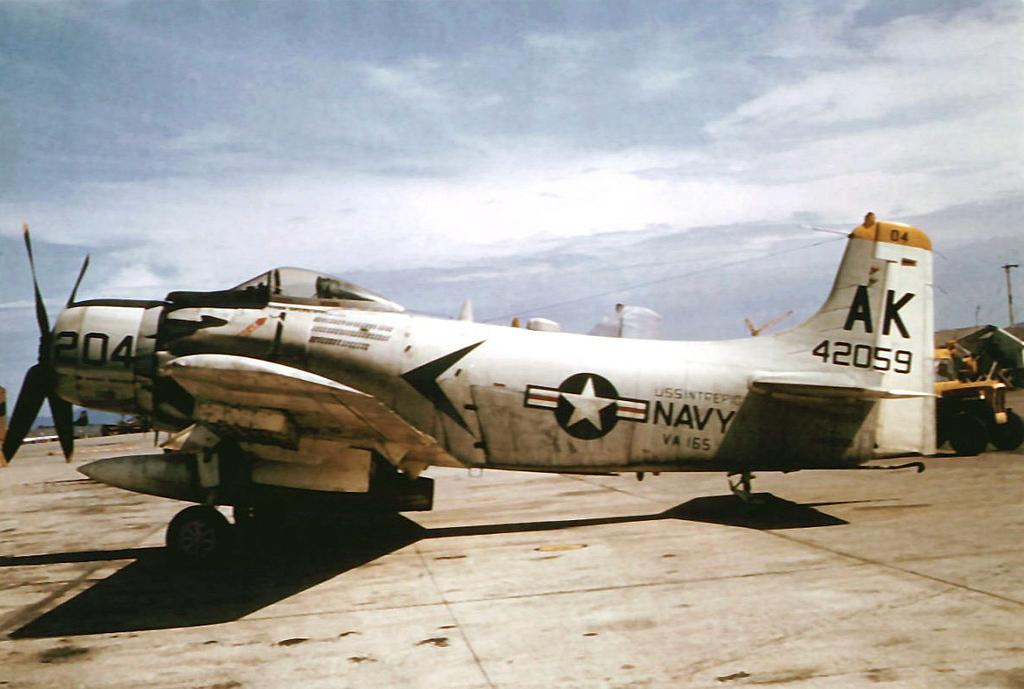What color is the aircraft in the image? The aircraft in the image is white. What is written on the aircraft? "NAVY" is written on the aircraft. What can be seen at the top of the image? The sky is visible at the top of the image. Where is the ornament located in the image? There is no ornament present in the image. What type of work is being done by the aircraft in the image? The image does not show the aircraft in action, so it is not possible to determine the type of work it is doing. 